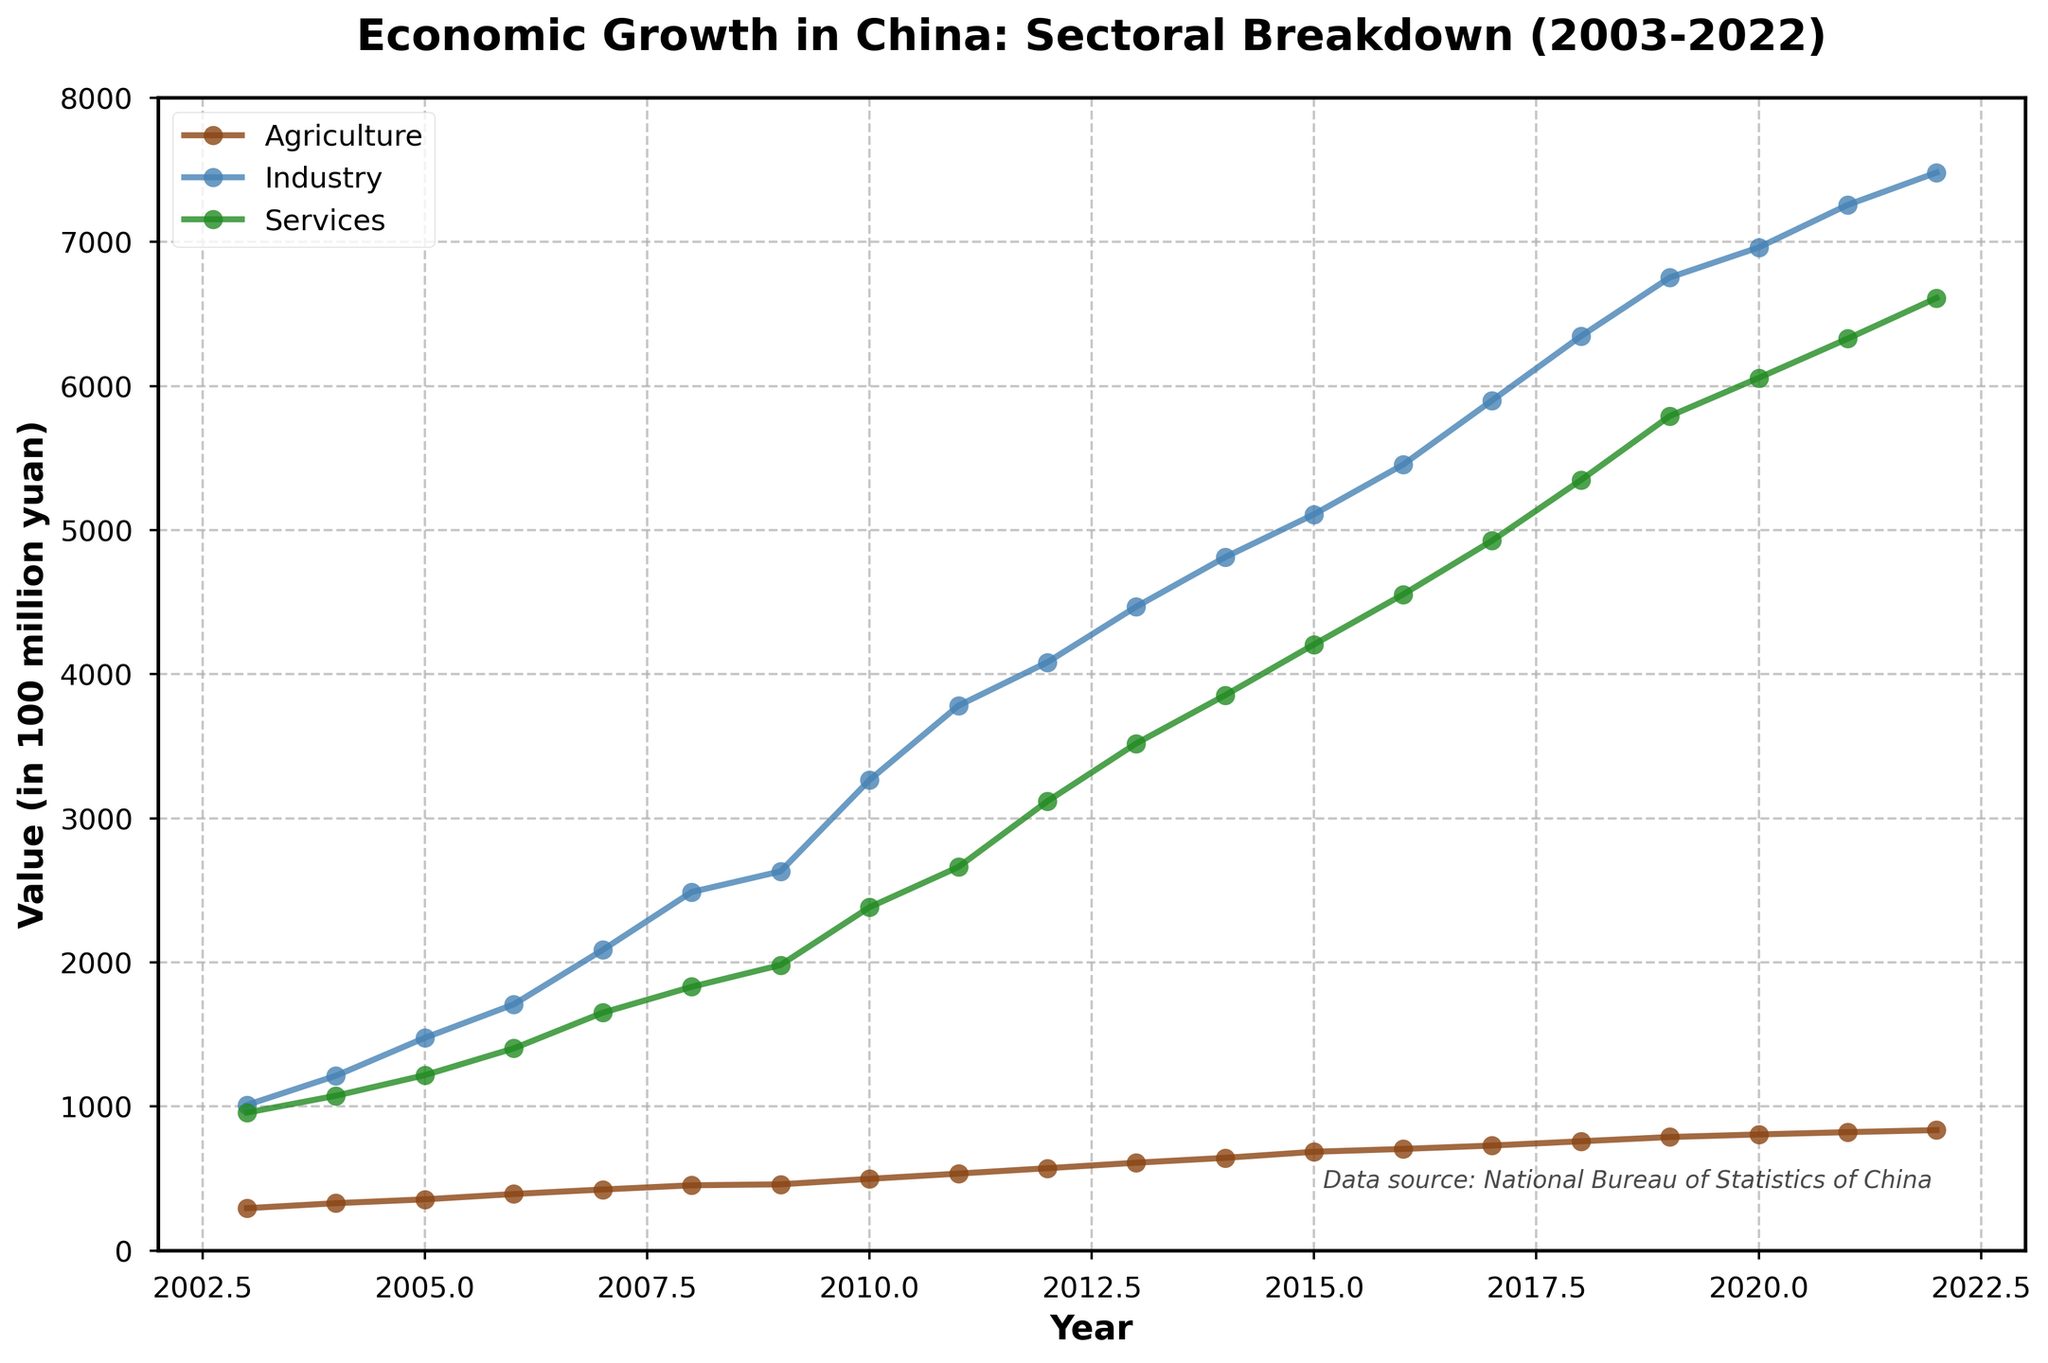What is the title of the plot? The plot's title can be found at the top center of the figure, which reads: "Economic Growth in China: Sectoral Breakdown (2003-2022)."
Answer: Economic Growth in China: Sectoral Breakdown (2003-2022) What are the units used on the y-axis? The y-axis label reads "Value (in 100 million yuan)," indicating the units used are in hundreds of millions of yuan.
Answer: Value (in 100 million yuan) Which sector saw the highest growth in 2022? By examining the endpoint of each line on the plot, it's clear the Industry sector has the highest value in 2022, surpassing both Agriculture and Services.
Answer: Industry Which sector had the least value in 2010? By locating the data points for each sector on the x-axis corresponding to 2010, we see that Agriculture, represented by the brown line, is the lowest among the three sectors in that year.
Answer: Agriculture What is the average value for Agriculture over the period 2003-2022? To calculate the average, sum the Agriculture values from each year and divide by the number of years (20). The sum is 12,188.2, and the average is 12,188.2 / 20.
Answer: 609.41 How did the Services sector perform relative to the Industry sector in 2008? Locate the data points for both Services and Industry in 2008. Services is about 1829.9 and Industry is 2488. This indicates that Industry outperformed Services in 2008.
Answer: Industry outperformed Services Between 2012 and 2014, which sector witnessed the highest increase in value? Calculate the change for each sector from 2012 to 2014: 
Agriculture: 643.2 - 571.2 = 72.0, 
Industry: 4811.5 - 4082.3 = 729.2, 
Services: 3853.7 - 3117.6 = 736.1. 
Comparing these changes, Services saw the highest increase.
Answer: Services What is the rate of increase in Agriculture from 2015 to 2018? The value for Agriculture in 2015 is 685.3 and in 2018 is 758.1. The change is 758.1 - 685.3 = 72.8 over 3 years, leading to an annual rate of 72.8 / 3.
Answer: 24.27 per year In what year did Industry first surpass 4000 units? Look for the year when the Industry line crosses the 4000 mark, which occurs in 2011.
Answer: 2011 